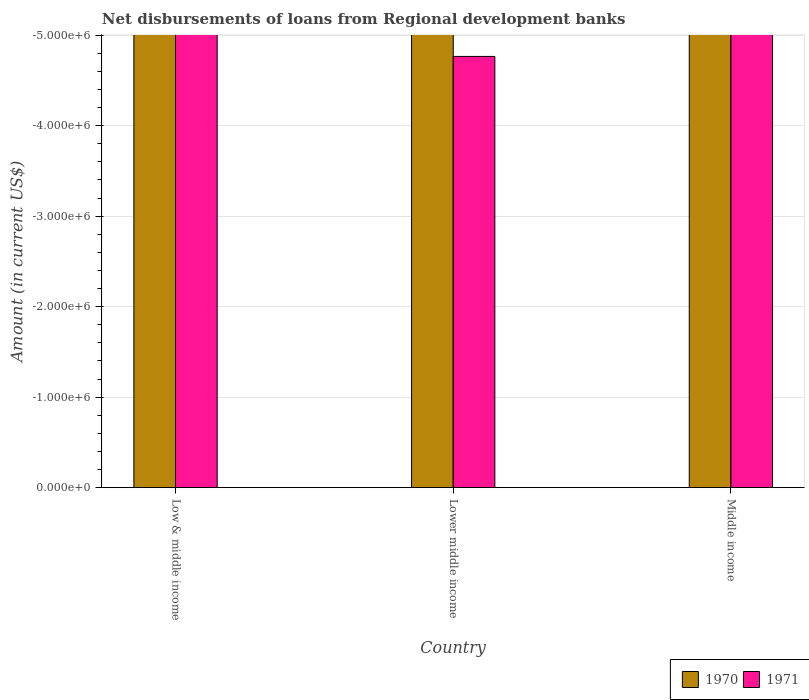Are the number of bars on each tick of the X-axis equal?
Provide a short and direct response. Yes. How many bars are there on the 3rd tick from the left?
Provide a short and direct response. 0. How many bars are there on the 2nd tick from the right?
Offer a very short reply. 0. What is the label of the 1st group of bars from the left?
Provide a succinct answer. Low & middle income. Across all countries, what is the minimum amount of disbursements of loans from regional development banks in 1970?
Offer a very short reply. 0. What is the difference between the amount of disbursements of loans from regional development banks in 1971 in Middle income and the amount of disbursements of loans from regional development banks in 1970 in Lower middle income?
Provide a succinct answer. 0. In how many countries, is the amount of disbursements of loans from regional development banks in 1970 greater than -1600000 US$?
Offer a terse response. 0. In how many countries, is the amount of disbursements of loans from regional development banks in 1970 greater than the average amount of disbursements of loans from regional development banks in 1970 taken over all countries?
Give a very brief answer. 0. Does the graph contain any zero values?
Your answer should be very brief. Yes. How many legend labels are there?
Provide a short and direct response. 2. How are the legend labels stacked?
Give a very brief answer. Horizontal. What is the title of the graph?
Offer a very short reply. Net disbursements of loans from Regional development banks. Does "1977" appear as one of the legend labels in the graph?
Provide a succinct answer. No. What is the label or title of the Y-axis?
Ensure brevity in your answer.  Amount (in current US$). What is the Amount (in current US$) of 1971 in Low & middle income?
Give a very brief answer. 0. What is the Amount (in current US$) in 1970 in Middle income?
Ensure brevity in your answer.  0. What is the total Amount (in current US$) of 1970 in the graph?
Make the answer very short. 0. What is the average Amount (in current US$) in 1970 per country?
Give a very brief answer. 0. What is the average Amount (in current US$) of 1971 per country?
Ensure brevity in your answer.  0. 